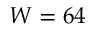<formula> <loc_0><loc_0><loc_500><loc_500>W = 6 4</formula> 